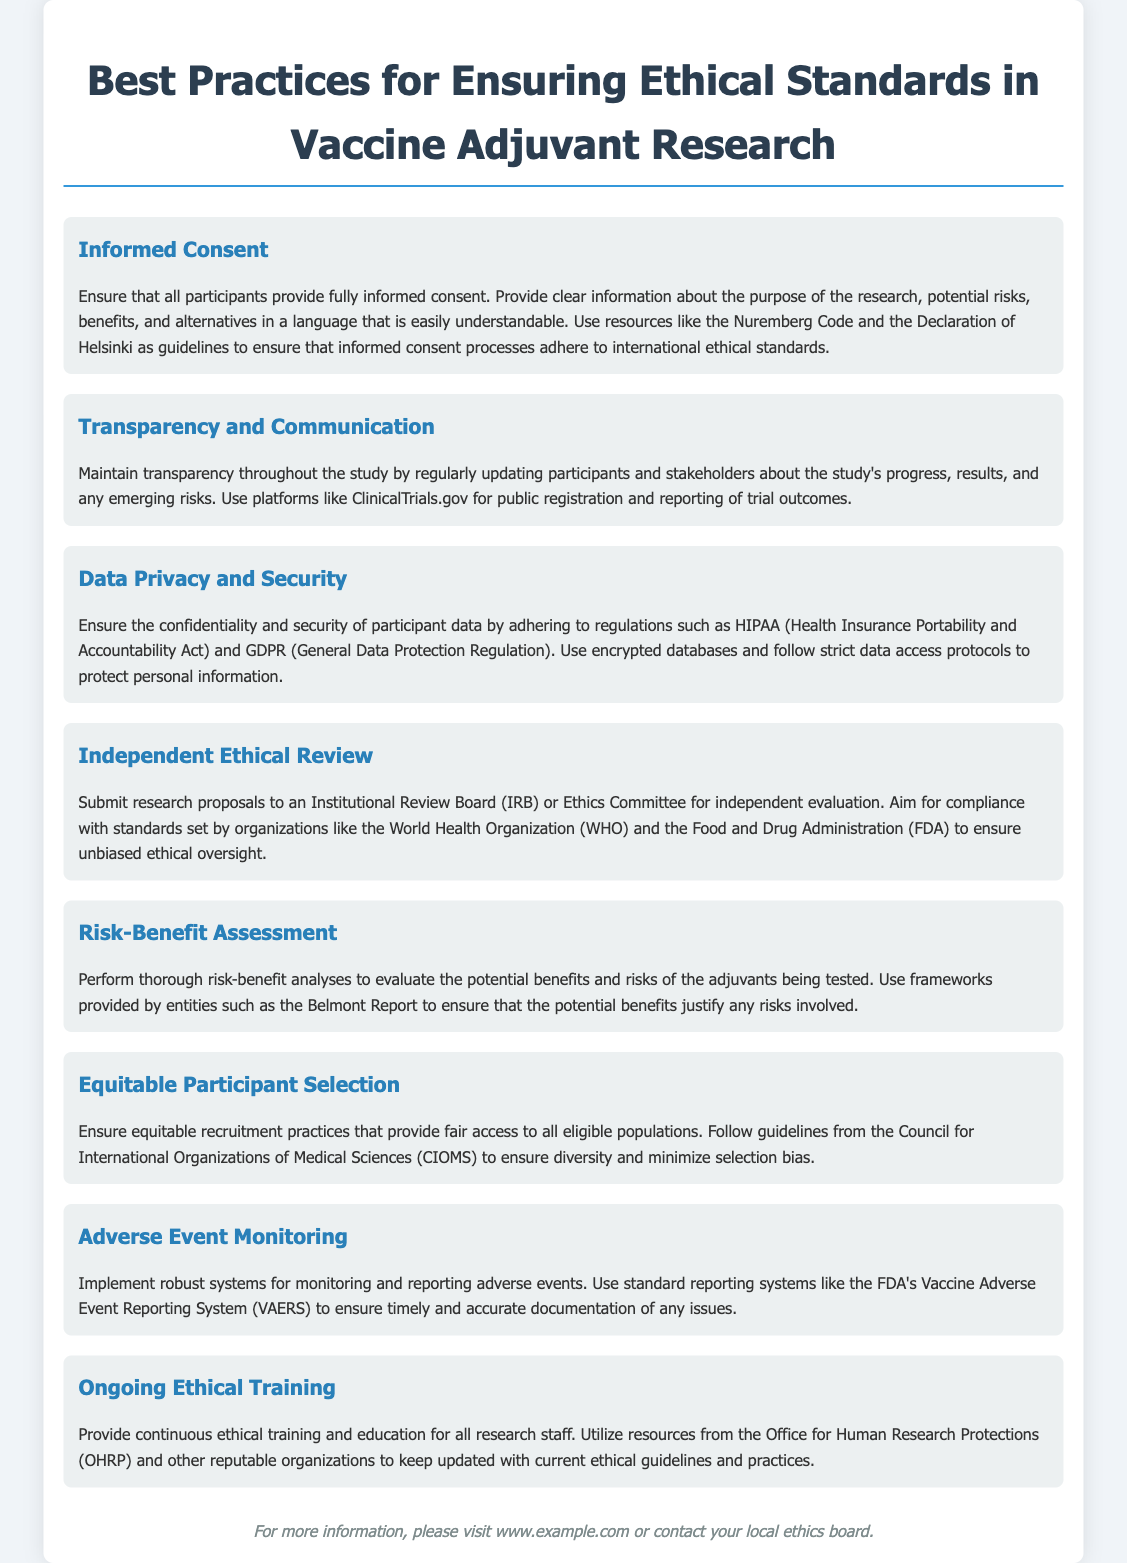What is the main title of the document? The title of the document is prominently displayed at the top and summarizes the content.
Answer: Best Practices for Ensuring Ethical Standards in Vaccine Adjuvant Research What is the first best practice mentioned? The document lists best practices in distinct sections, starting with informed consent.
Answer: Informed Consent Which organization’s standards should be followed for ethical review? The document states that research proposals should comply with standards set by certain organizations.
Answer: World Health Organization (WHO) and the Food and Drug Administration (FDA) What does the document suggest for data privacy? Data privacy and security guidelines are provided, mentioning specific regulations to follow.
Answer: HIPAA and GDPR What system is recommended for monitoring adverse events? The document specifies a standard reporting system used for this purpose.
Answer: FDA's Vaccine Adverse Event Reporting System (VAERS) What type of training is recommended for research staff? The document emphasizes continuous training for ethical practices among staff members.
Answer: Ongoing Ethical Training How should participants be selected according to the document? It presents guidelines for participant selection to ensure fair practices.
Answer: Equitable recruitment practices What framework is recommended for risk-benefit assessment? A specific document that outlines ethical principles for evaluation is mentioned.
Answer: Belmont Report 